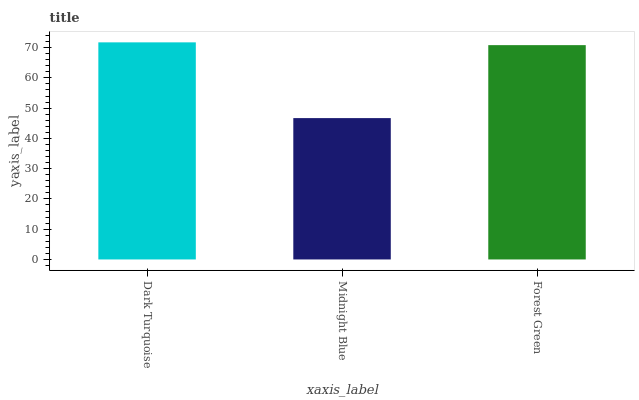Is Midnight Blue the minimum?
Answer yes or no. Yes. Is Dark Turquoise the maximum?
Answer yes or no. Yes. Is Forest Green the minimum?
Answer yes or no. No. Is Forest Green the maximum?
Answer yes or no. No. Is Forest Green greater than Midnight Blue?
Answer yes or no. Yes. Is Midnight Blue less than Forest Green?
Answer yes or no. Yes. Is Midnight Blue greater than Forest Green?
Answer yes or no. No. Is Forest Green less than Midnight Blue?
Answer yes or no. No. Is Forest Green the high median?
Answer yes or no. Yes. Is Forest Green the low median?
Answer yes or no. Yes. Is Dark Turquoise the high median?
Answer yes or no. No. Is Midnight Blue the low median?
Answer yes or no. No. 